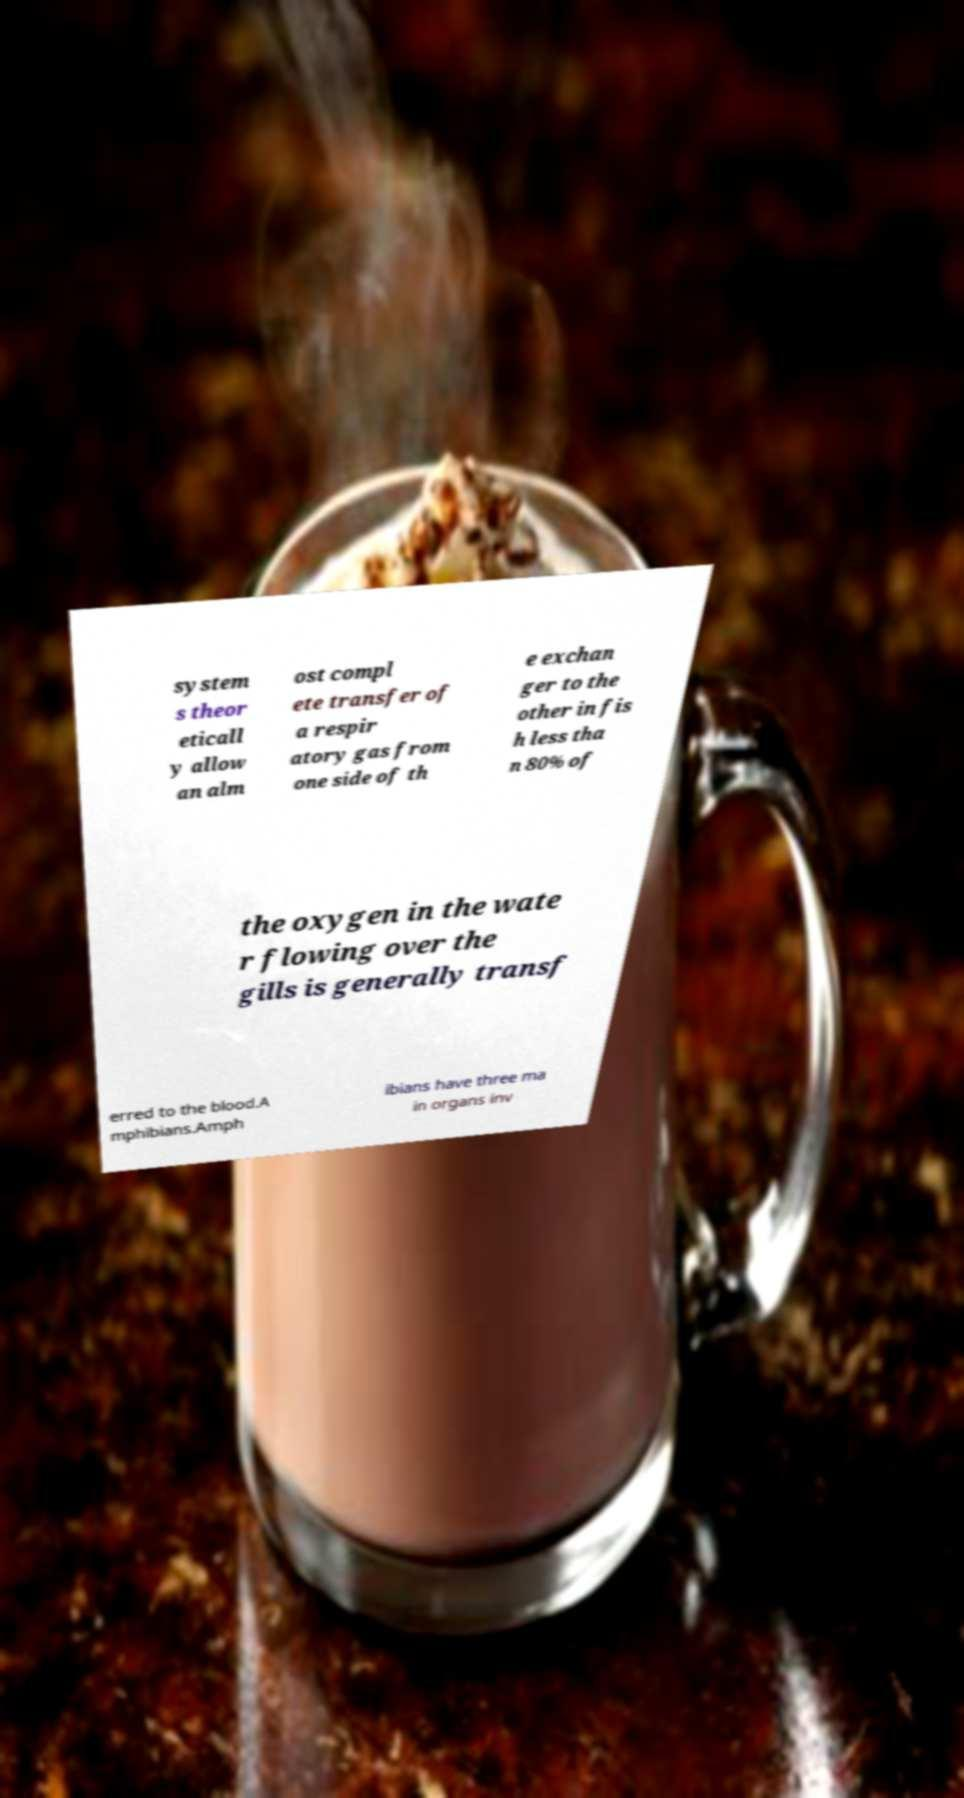Could you assist in decoding the text presented in this image and type it out clearly? system s theor eticall y allow an alm ost compl ete transfer of a respir atory gas from one side of th e exchan ger to the other in fis h less tha n 80% of the oxygen in the wate r flowing over the gills is generally transf erred to the blood.A mphibians.Amph ibians have three ma in organs inv 